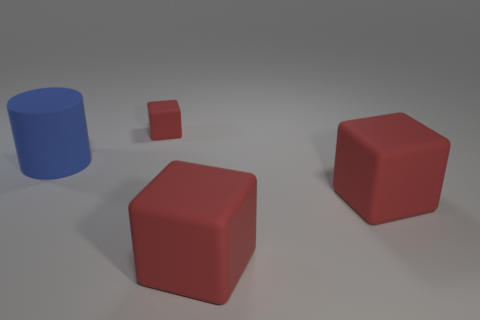There is a thing behind the big blue matte thing; is its shape the same as the object on the left side of the tiny red cube?
Offer a very short reply. No. How many big red blocks have the same material as the blue cylinder?
Offer a terse response. 2. Is the cube behind the blue cylinder made of the same material as the big blue object?
Ensure brevity in your answer.  Yes. Are there any other cubes that have the same color as the small rubber block?
Offer a terse response. Yes. There is a blue thing that is made of the same material as the small cube; what is its size?
Provide a succinct answer. Large. There is a red cube behind the cylinder; what material is it?
Ensure brevity in your answer.  Rubber. What is the shape of the large rubber object that is to the left of the red thing that is behind the large matte thing on the left side of the small red cube?
Offer a terse response. Cylinder. What number of things are large blue rubber things or blocks that are behind the big cylinder?
Provide a succinct answer. 2. What number of things are either red objects on the right side of the small block or red things that are behind the blue rubber cylinder?
Provide a short and direct response. 3. Are there any big blue cylinders in front of the blue rubber cylinder?
Offer a terse response. No. 